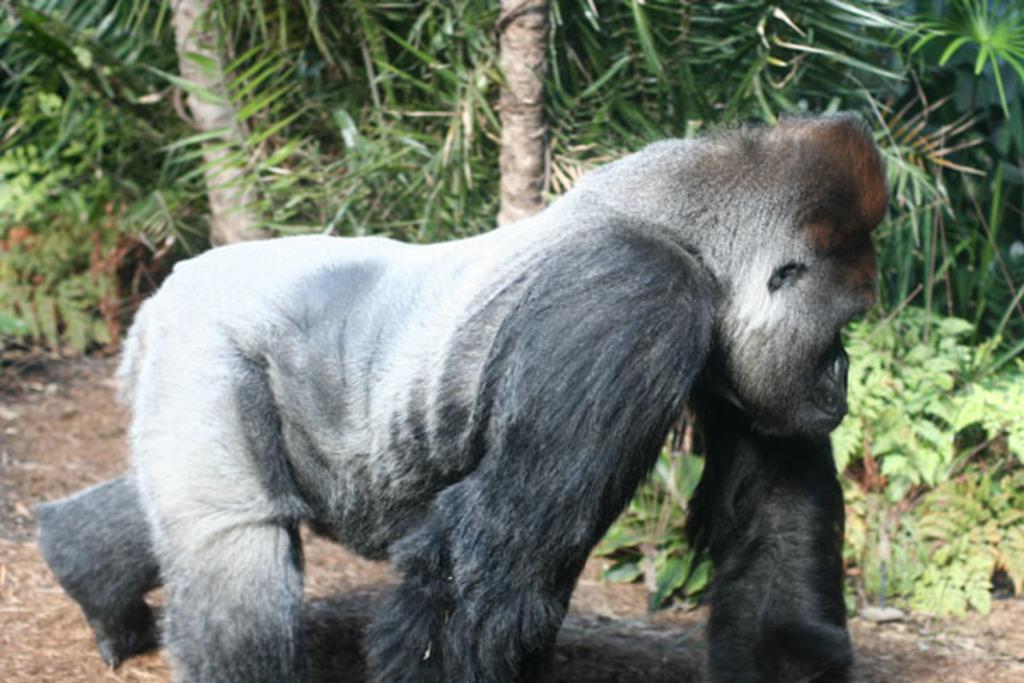Can you describe this image briefly? In this picture we can see a gorilla walking on the land, side we can see some trees and plants. 